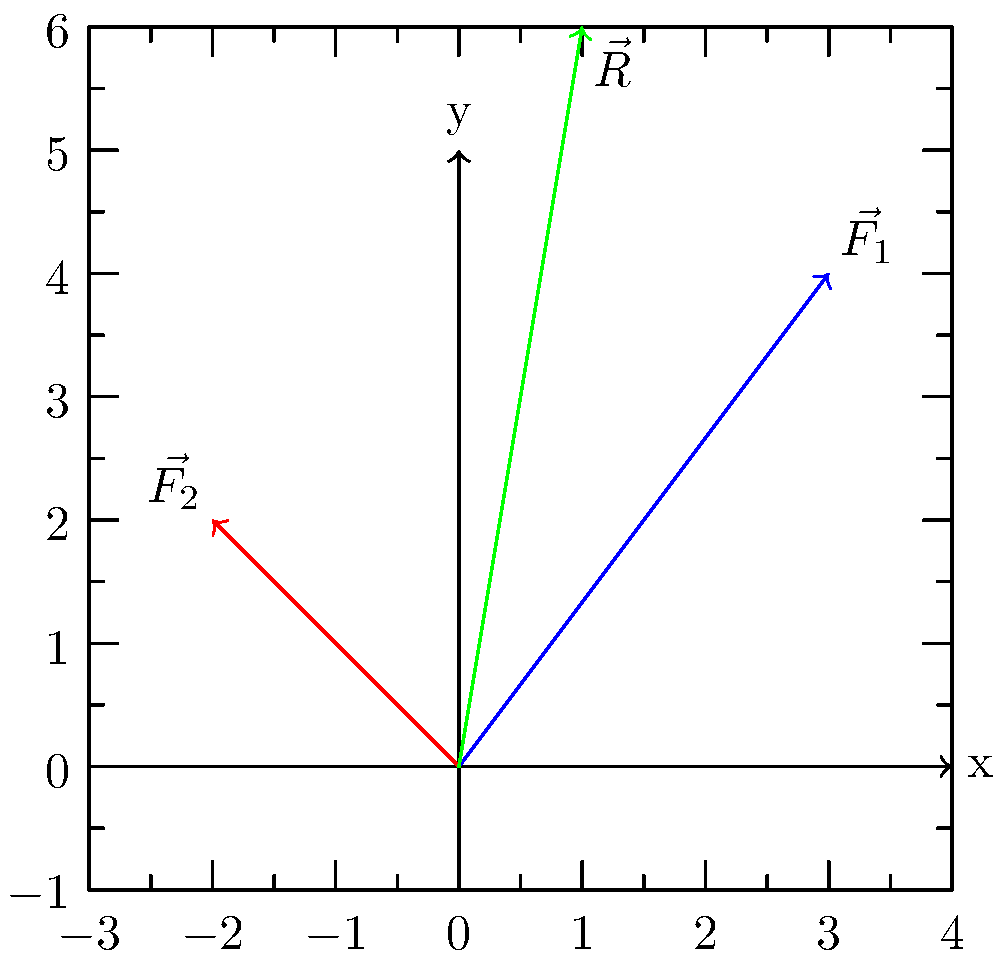While climbing the Andes mountains near Santiago, you encounter a steep section. Your weight vector is represented by $\vec{F_2} = -2\hat{i} + 2\hat{j}$ (in kN), and you apply a force $\vec{F_1} = 3\hat{i} + 4\hat{j}$ (in kN) to pull yourself up. What is the magnitude of the resultant force vector $\vec{R}$? To find the magnitude of the resultant force vector, we need to follow these steps:

1) The resultant force vector $\vec{R}$ is the sum of the two force vectors:
   $\vec{R} = \vec{F_1} + \vec{F_2}$

2) Let's add the vectors component-wise:
   $\vec{R} = (3\hat{i} + 4\hat{j}) + (-2\hat{i} + 2\hat{j})$
   $\vec{R} = (3-2)\hat{i} + (4+2)\hat{j}$
   $\vec{R} = 1\hat{i} + 6\hat{j}$

3) Now that we have the components of $\vec{R}$, we can find its magnitude using the Pythagorean theorem:
   $|\vec{R}| = \sqrt{(1)^2 + (6)^2}$

4) Simplify:
   $|\vec{R}| = \sqrt{1 + 36} = \sqrt{37}$

5) The square root of 37 is approximately 6.08 kN.

Therefore, the magnitude of the resultant force vector is approximately 6.08 kN.
Answer: $\sqrt{37}$ kN $\approx 6.08$ kN 